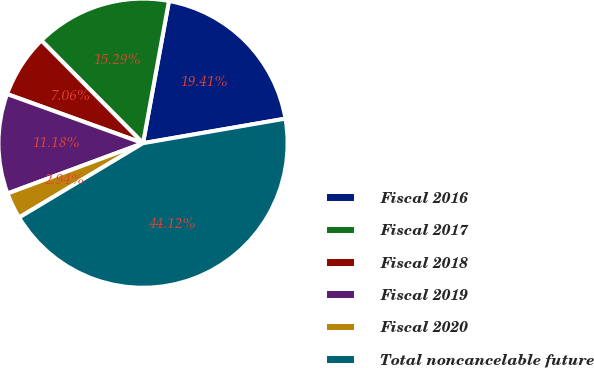<chart> <loc_0><loc_0><loc_500><loc_500><pie_chart><fcel>Fiscal 2016<fcel>Fiscal 2017<fcel>Fiscal 2018<fcel>Fiscal 2019<fcel>Fiscal 2020<fcel>Total noncancelable future<nl><fcel>19.41%<fcel>15.29%<fcel>7.06%<fcel>11.18%<fcel>2.94%<fcel>44.12%<nl></chart> 